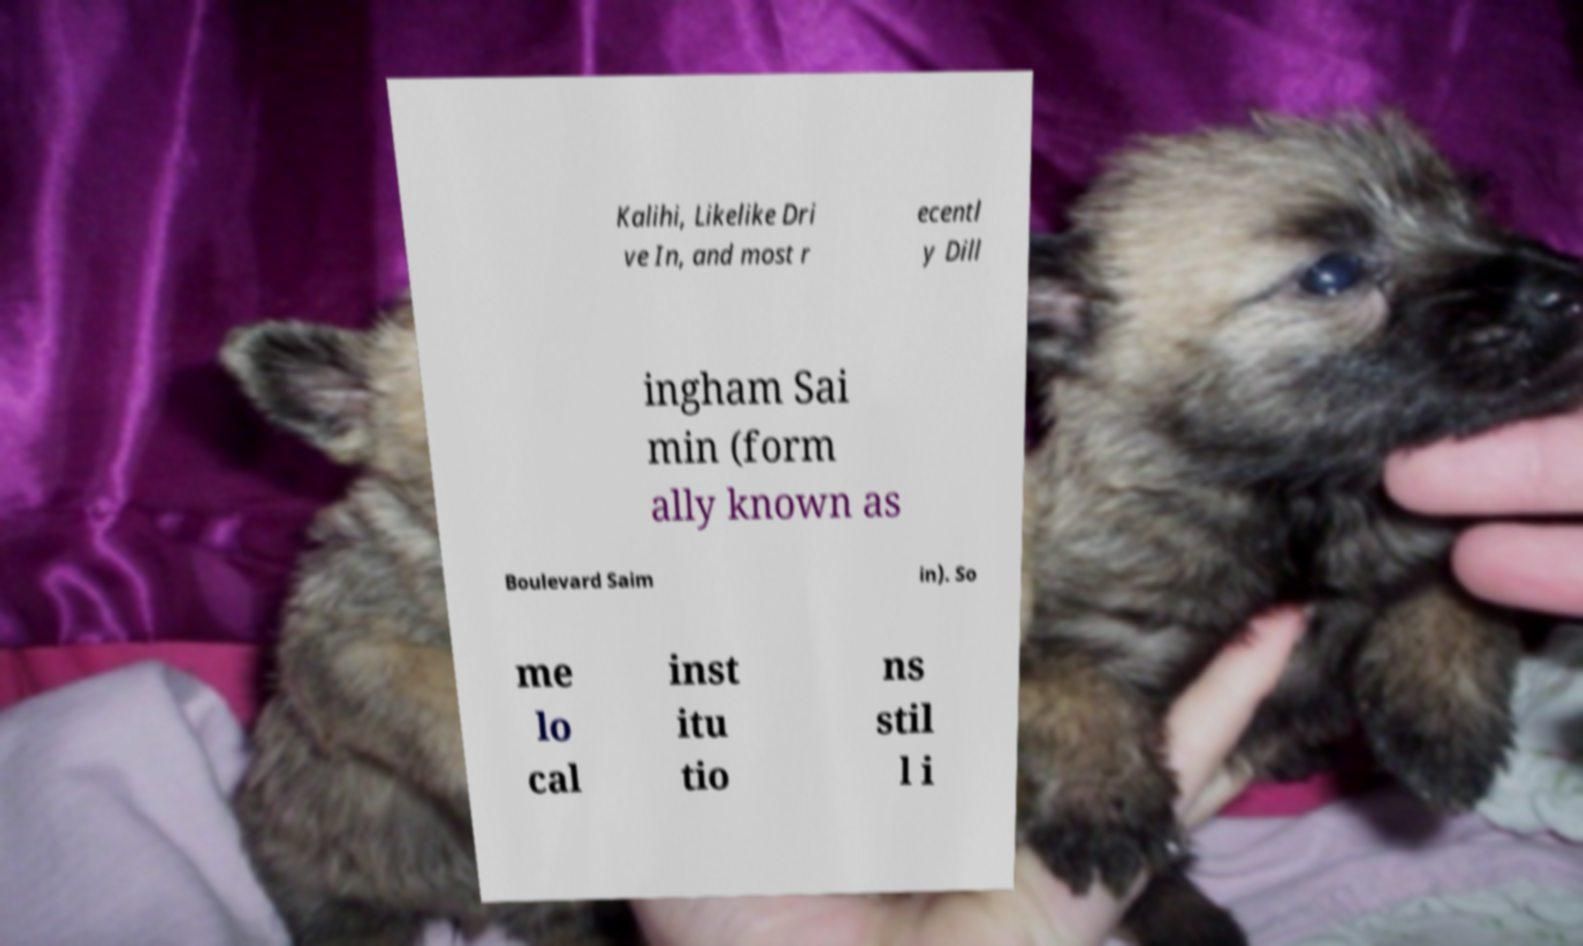Could you assist in decoding the text presented in this image and type it out clearly? Kalihi, Likelike Dri ve In, and most r ecentl y Dill ingham Sai min (form ally known as Boulevard Saim in). So me lo cal inst itu tio ns stil l i 